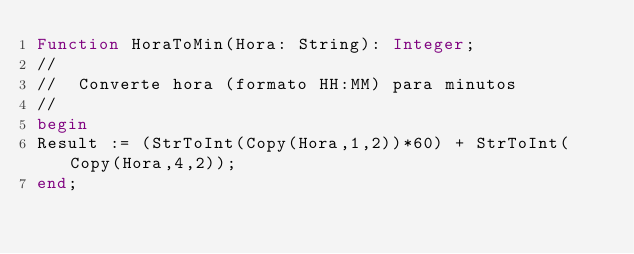<code> <loc_0><loc_0><loc_500><loc_500><_Pascal_>Function HoraToMin(Hora: String): Integer;
//
//  Converte hora (formato HH:MM) para minutos
//
begin
Result := (StrToInt(Copy(Hora,1,2))*60) + StrToInt(Copy(Hora,4,2));
end;
</code> 